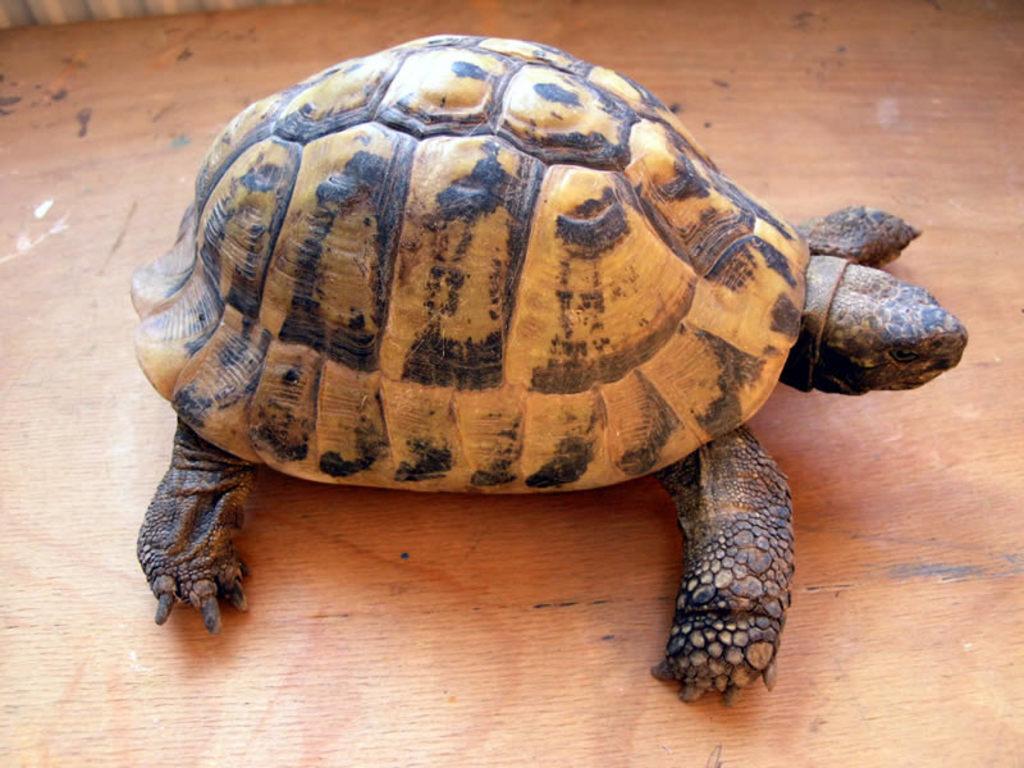Can you describe this image briefly? In the picture we can see a wooden plank on it we can see a tortoise. 